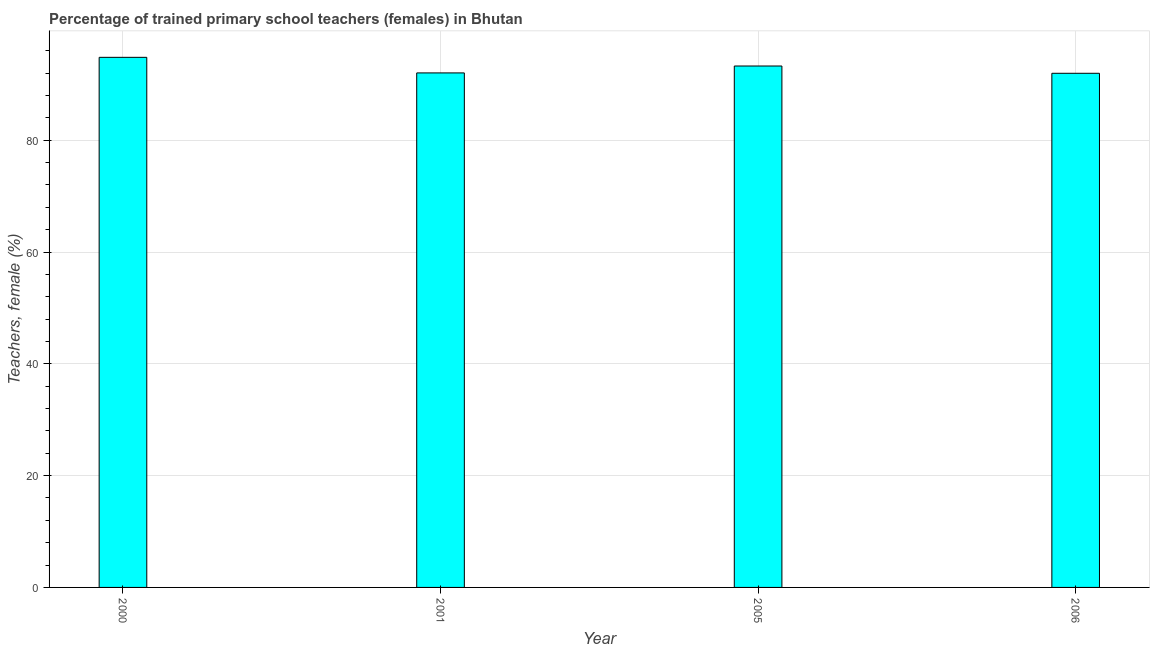Does the graph contain any zero values?
Your answer should be very brief. No. What is the title of the graph?
Provide a succinct answer. Percentage of trained primary school teachers (females) in Bhutan. What is the label or title of the X-axis?
Your response must be concise. Year. What is the label or title of the Y-axis?
Give a very brief answer. Teachers, female (%). What is the percentage of trained female teachers in 2006?
Offer a very short reply. 91.98. Across all years, what is the maximum percentage of trained female teachers?
Your answer should be compact. 94.83. Across all years, what is the minimum percentage of trained female teachers?
Keep it short and to the point. 91.98. In which year was the percentage of trained female teachers maximum?
Ensure brevity in your answer.  2000. What is the sum of the percentage of trained female teachers?
Your answer should be very brief. 372.14. What is the difference between the percentage of trained female teachers in 2001 and 2005?
Ensure brevity in your answer.  -1.24. What is the average percentage of trained female teachers per year?
Your answer should be compact. 93.04. What is the median percentage of trained female teachers?
Offer a very short reply. 92.66. Do a majority of the years between 2000 and 2005 (inclusive) have percentage of trained female teachers greater than 32 %?
Make the answer very short. Yes. What is the ratio of the percentage of trained female teachers in 2000 to that in 2005?
Your answer should be compact. 1.02. Is the difference between the percentage of trained female teachers in 2000 and 2005 greater than the difference between any two years?
Offer a very short reply. No. What is the difference between the highest and the second highest percentage of trained female teachers?
Make the answer very short. 1.55. What is the difference between the highest and the lowest percentage of trained female teachers?
Your answer should be compact. 2.85. How many bars are there?
Provide a short and direct response. 4. What is the difference between two consecutive major ticks on the Y-axis?
Your response must be concise. 20. What is the Teachers, female (%) of 2000?
Ensure brevity in your answer.  94.83. What is the Teachers, female (%) of 2001?
Give a very brief answer. 92.05. What is the Teachers, female (%) of 2005?
Make the answer very short. 93.28. What is the Teachers, female (%) of 2006?
Your response must be concise. 91.98. What is the difference between the Teachers, female (%) in 2000 and 2001?
Offer a terse response. 2.79. What is the difference between the Teachers, female (%) in 2000 and 2005?
Provide a short and direct response. 1.55. What is the difference between the Teachers, female (%) in 2000 and 2006?
Provide a succinct answer. 2.85. What is the difference between the Teachers, female (%) in 2001 and 2005?
Offer a very short reply. -1.24. What is the difference between the Teachers, female (%) in 2001 and 2006?
Provide a short and direct response. 0.07. What is the difference between the Teachers, female (%) in 2005 and 2006?
Your answer should be compact. 1.3. What is the ratio of the Teachers, female (%) in 2000 to that in 2001?
Keep it short and to the point. 1.03. What is the ratio of the Teachers, female (%) in 2000 to that in 2005?
Ensure brevity in your answer.  1.02. What is the ratio of the Teachers, female (%) in 2000 to that in 2006?
Provide a short and direct response. 1.03. 